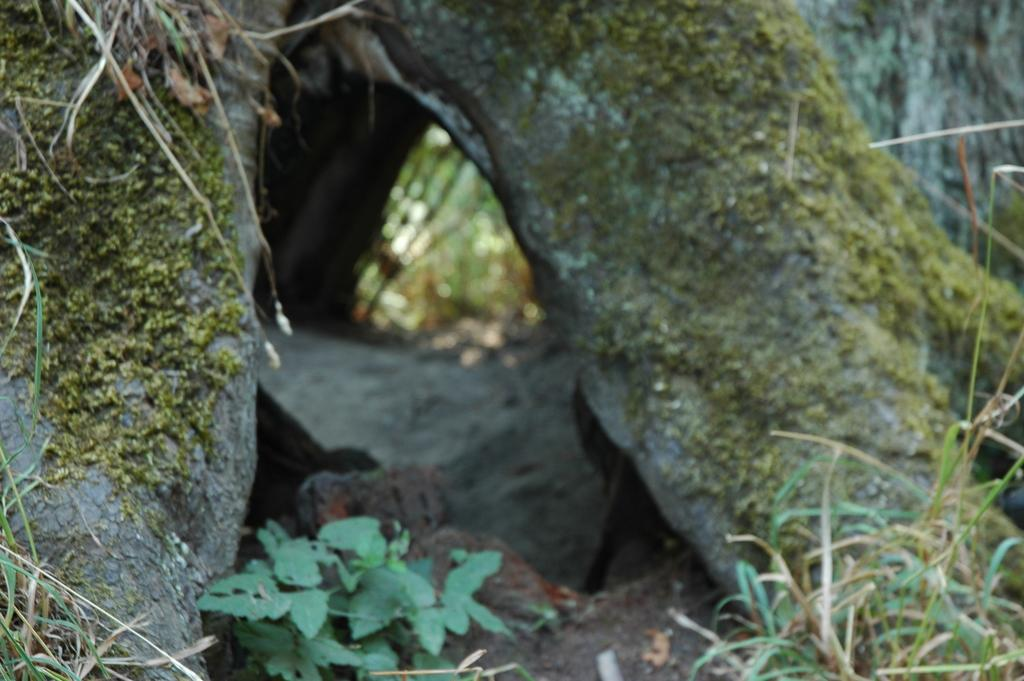What is present on the tree branch in the image? There is mold on the tree branch in the image. What type of vegetation can be seen in the image? There are grass plants and a plant sapling in the image. What is the condition of the grass in the image? There is dried grass in the image. What type of brick can be seen in the image? There is no brick present in the image. What view can be seen from the plant sapling in the image? The image does not provide a view from the plant sapling, as it is a still image. 